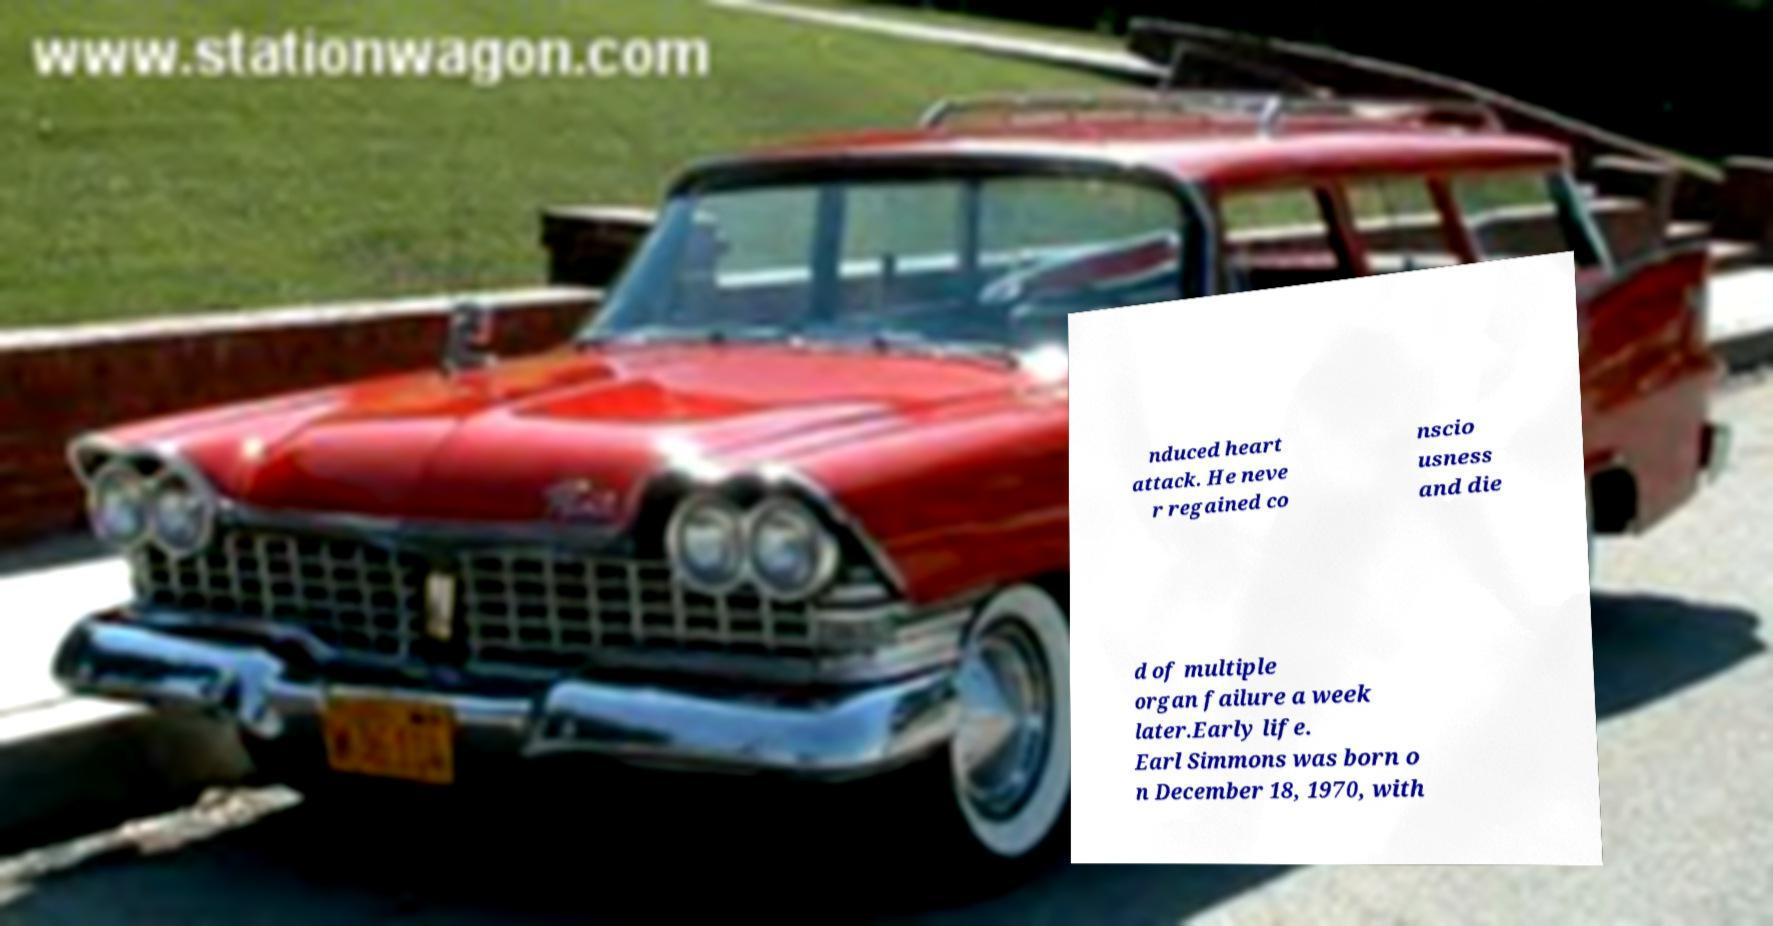Can you read and provide the text displayed in the image?This photo seems to have some interesting text. Can you extract and type it out for me? nduced heart attack. He neve r regained co nscio usness and die d of multiple organ failure a week later.Early life. Earl Simmons was born o n December 18, 1970, with 